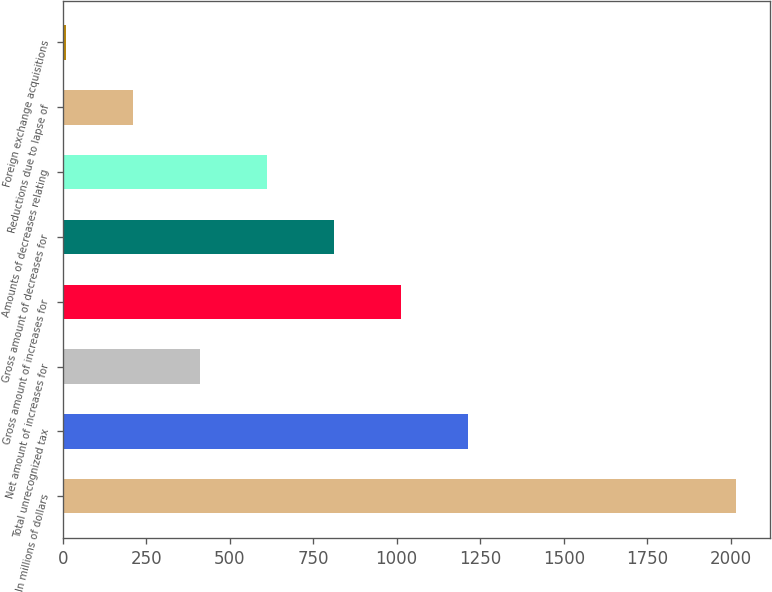Convert chart to OTSL. <chart><loc_0><loc_0><loc_500><loc_500><bar_chart><fcel>In millions of dollars<fcel>Total unrecognized tax<fcel>Net amount of increases for<fcel>Gross amount of increases for<fcel>Gross amount of decreases for<fcel>Amounts of decreases relating<fcel>Reductions due to lapse of<fcel>Foreign exchange acquisitions<nl><fcel>2017<fcel>1214.2<fcel>411.4<fcel>1013.5<fcel>812.8<fcel>612.1<fcel>210.7<fcel>10<nl></chart> 